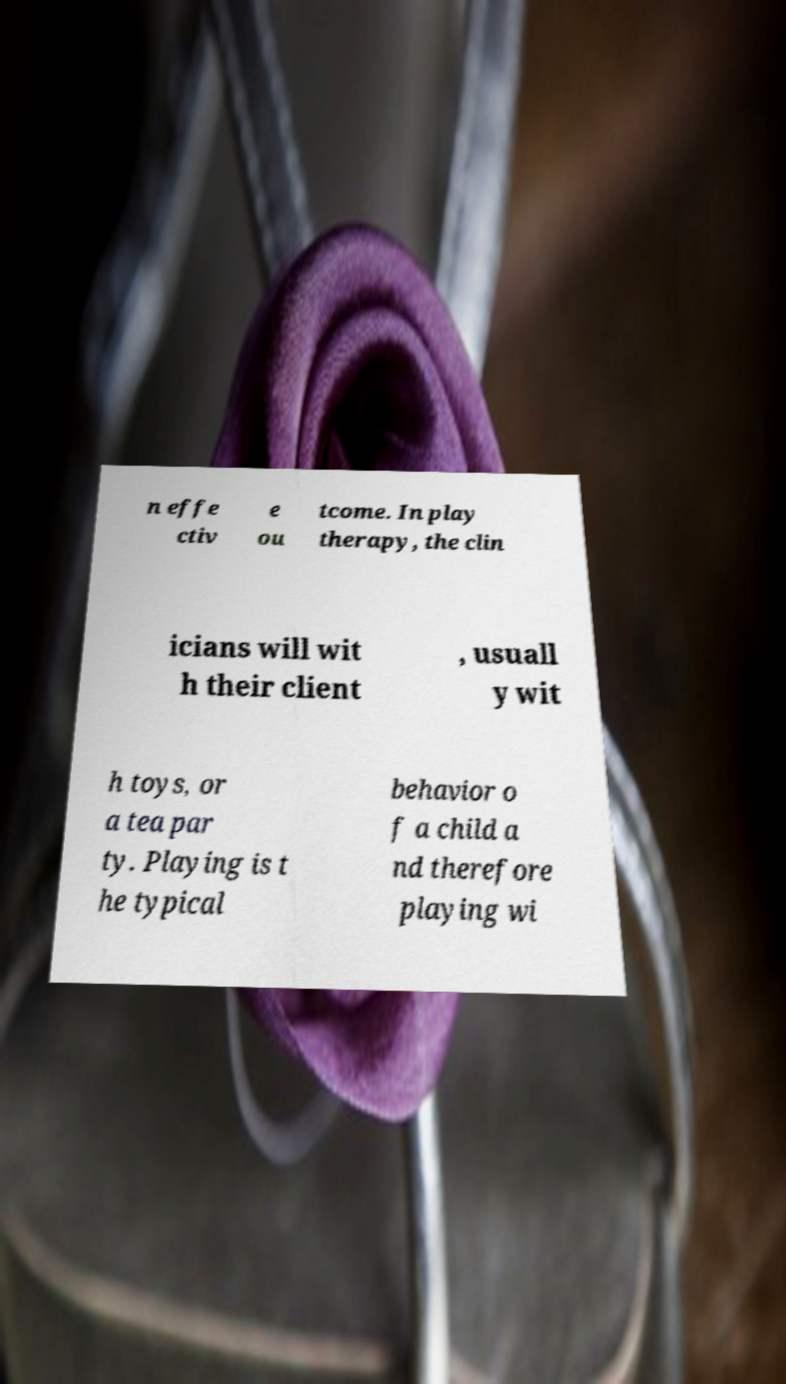I need the written content from this picture converted into text. Can you do that? n effe ctiv e ou tcome. In play therapy, the clin icians will wit h their client , usuall y wit h toys, or a tea par ty. Playing is t he typical behavior o f a child a nd therefore playing wi 